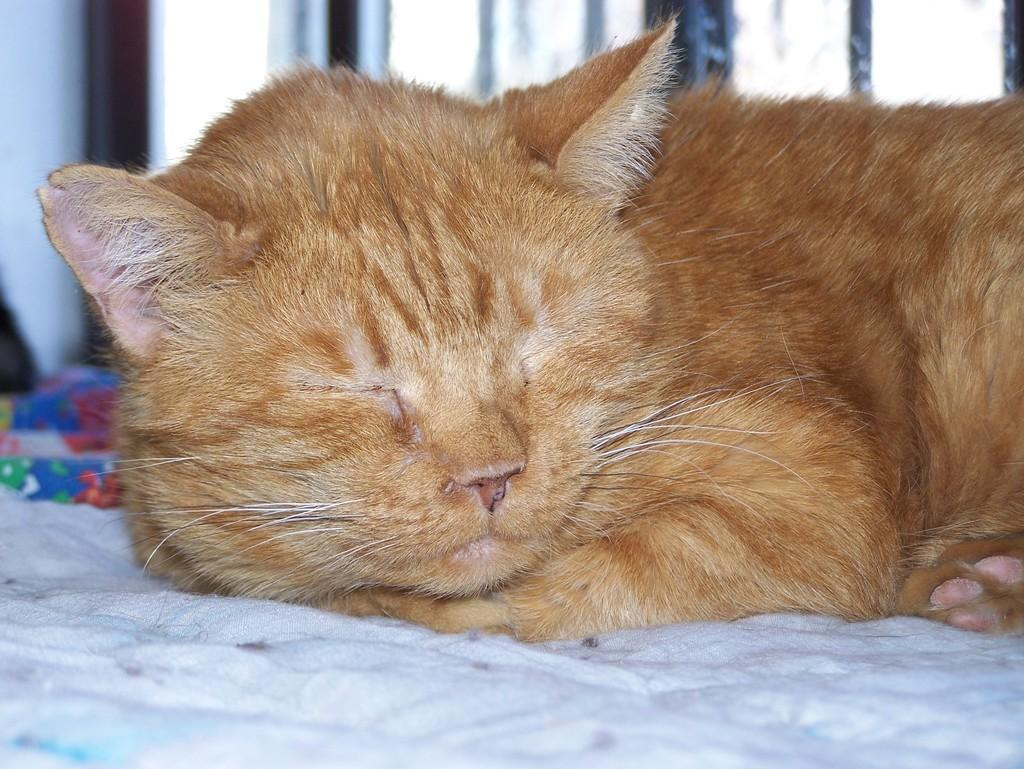What type of animal is in the image? There is a cat in the image. What is the cat doing in the image? The cat is sleeping. Where is the cat located in the image? The cat is on a cloth. What can be seen in the background of the image? There are windows visible in the background of the image. What type of haircut does the cat have in the image? There is no mention of a haircut in the image, as the focus is on the cat's sleeping position and location. 